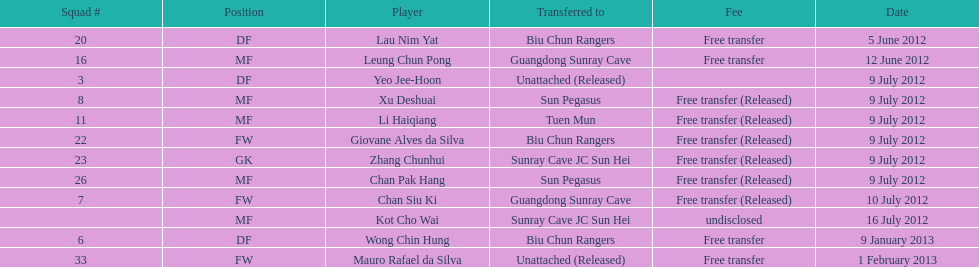What is the total number of players listed? 12. 